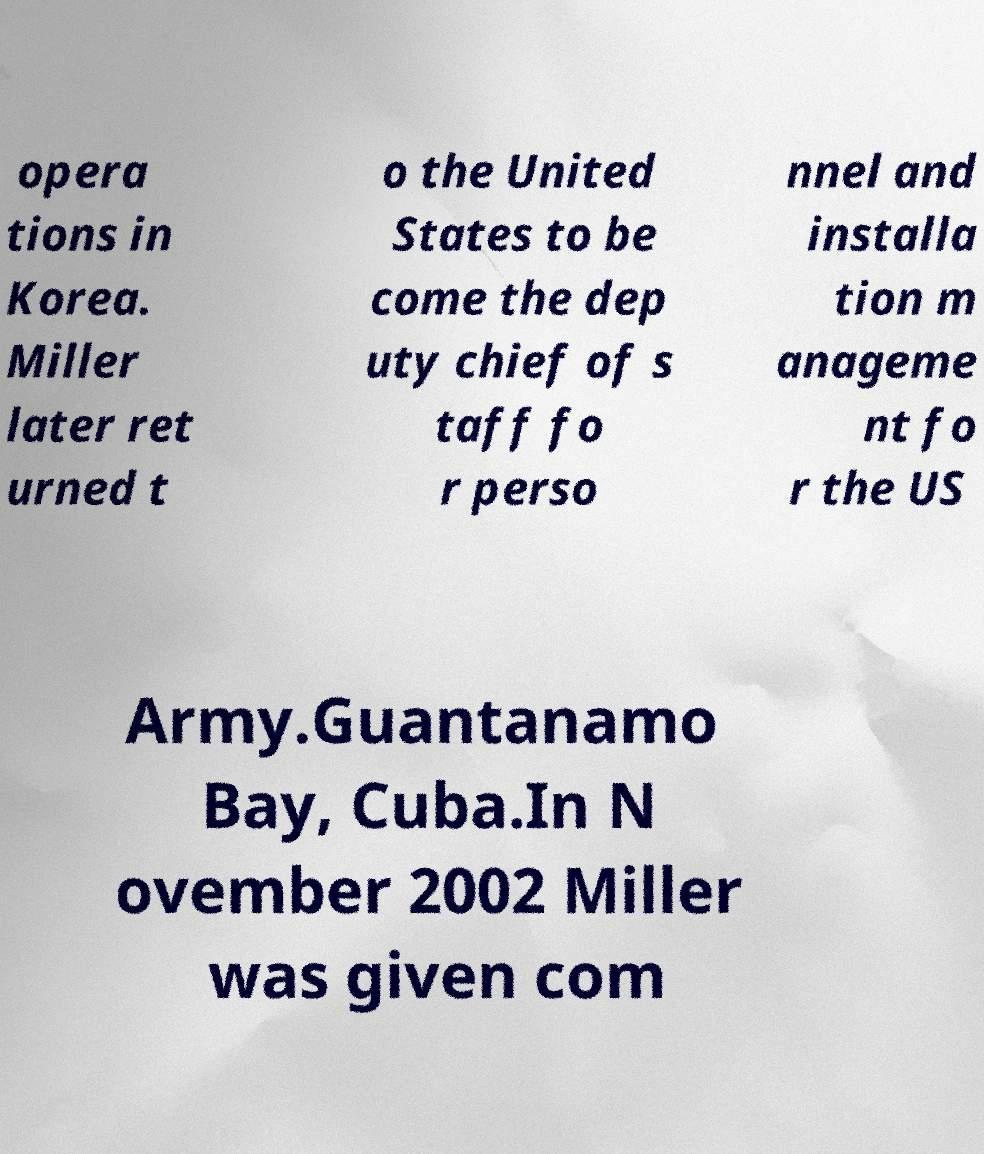Please identify and transcribe the text found in this image. opera tions in Korea. Miller later ret urned t o the United States to be come the dep uty chief of s taff fo r perso nnel and installa tion m anageme nt fo r the US Army.Guantanamo Bay, Cuba.In N ovember 2002 Miller was given com 